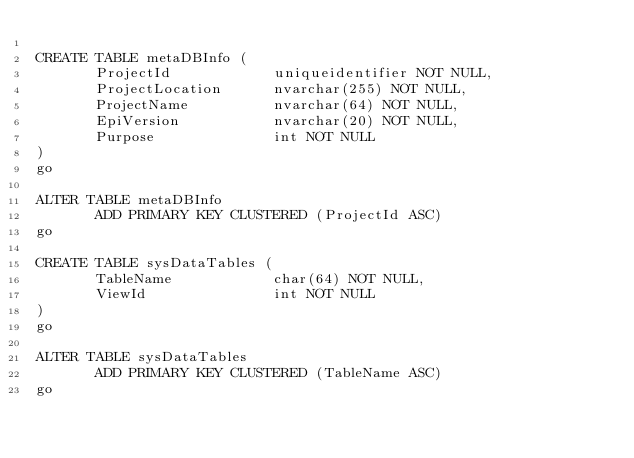Convert code to text. <code><loc_0><loc_0><loc_500><loc_500><_SQL_>
CREATE TABLE metaDBInfo (
       ProjectId            uniqueidentifier NOT NULL,
       ProjectLocation      nvarchar(255) NOT NULL,
       ProjectName          nvarchar(64) NOT NULL,
       EpiVersion           nvarchar(20) NOT NULL,
       Purpose              int NOT NULL
)
go

ALTER TABLE metaDBInfo
       ADD PRIMARY KEY CLUSTERED (ProjectId ASC)
go

CREATE TABLE sysDataTables (
       TableName            char(64) NOT NULL,
       ViewId               int NOT NULL
)
go

ALTER TABLE sysDataTables
       ADD PRIMARY KEY CLUSTERED (TableName ASC)
go



</code> 